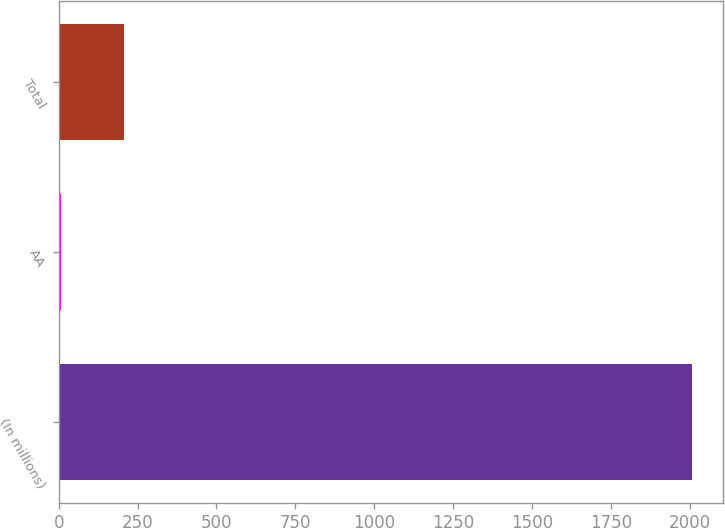<chart> <loc_0><loc_0><loc_500><loc_500><bar_chart><fcel>(In millions)<fcel>AA<fcel>Total<nl><fcel>2006<fcel>7<fcel>206.9<nl></chart> 